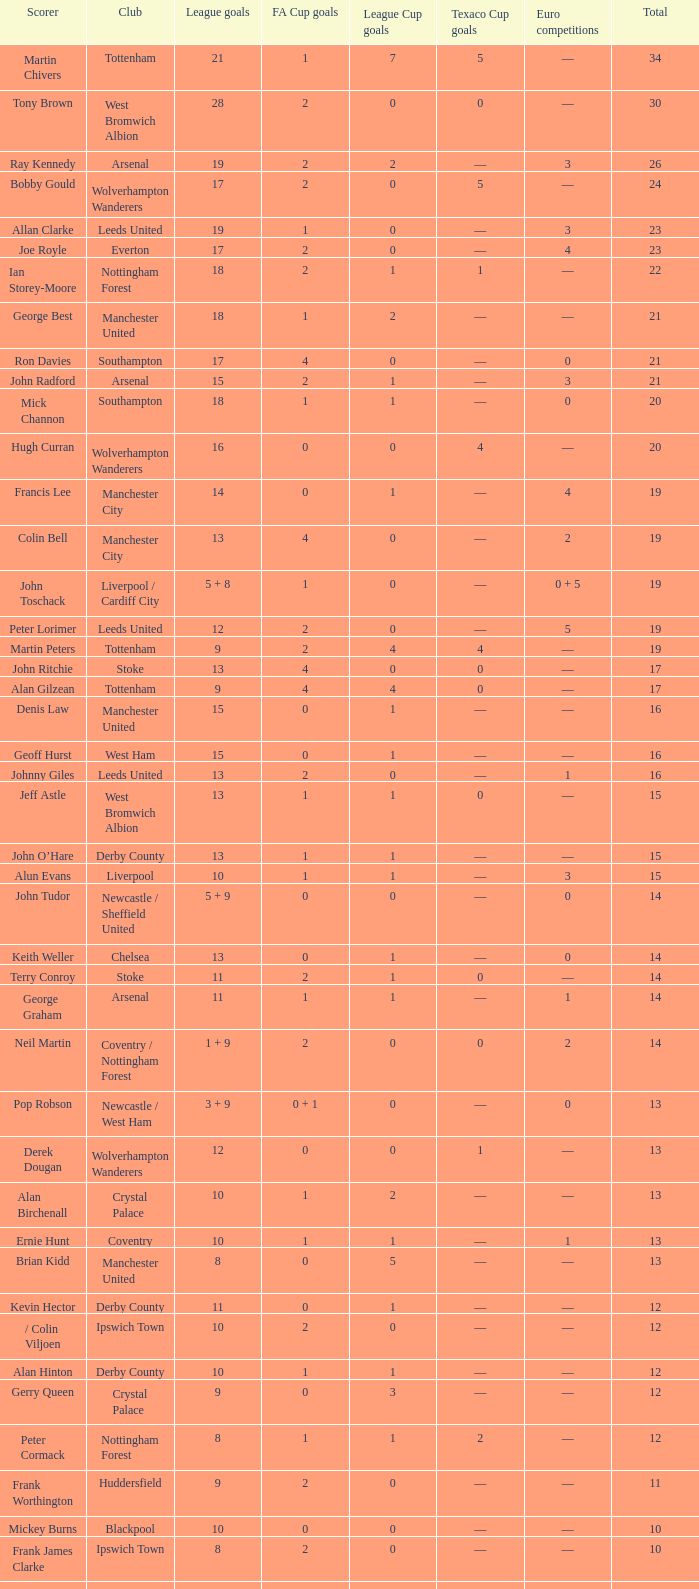What is the standard total, when fa cup goals is 1, when league goals is 10, and when club is crystal palace? 13.0. 